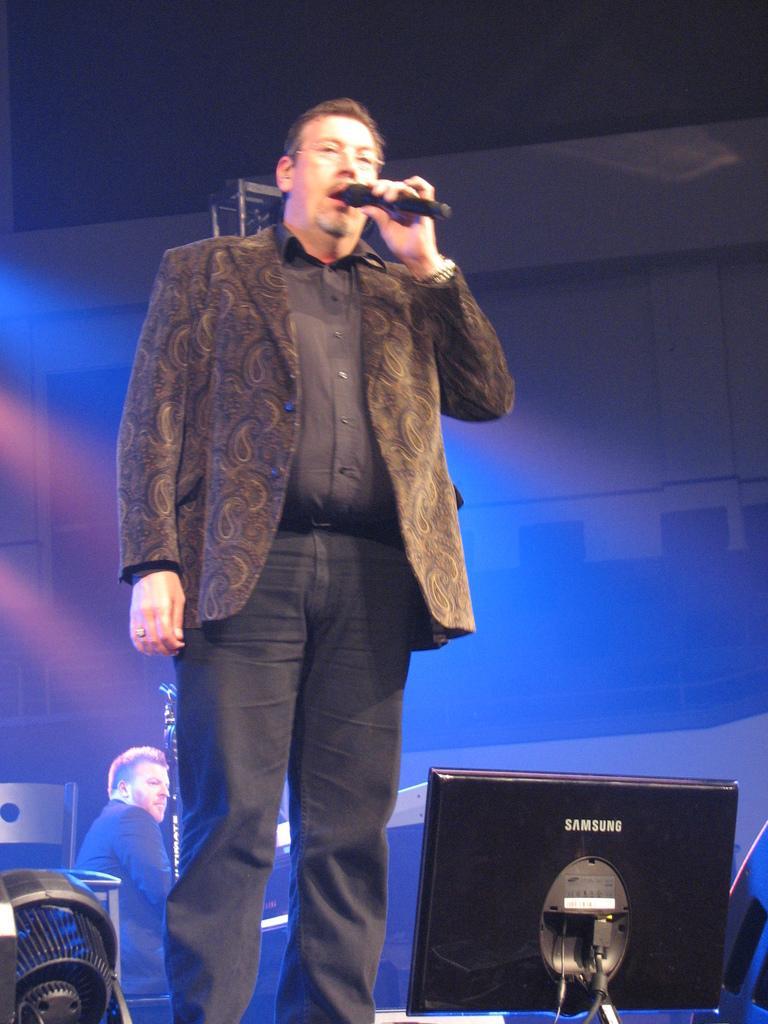In one or two sentences, can you explain what this image depicts? In the middle of the image a person is standing and holding a microphone. In the bottom right corner of the image we can see a monitor. In the bottom left corner of the image we can see some object. Behind the object a person is sitting. At the top of the image we can see a wall. 